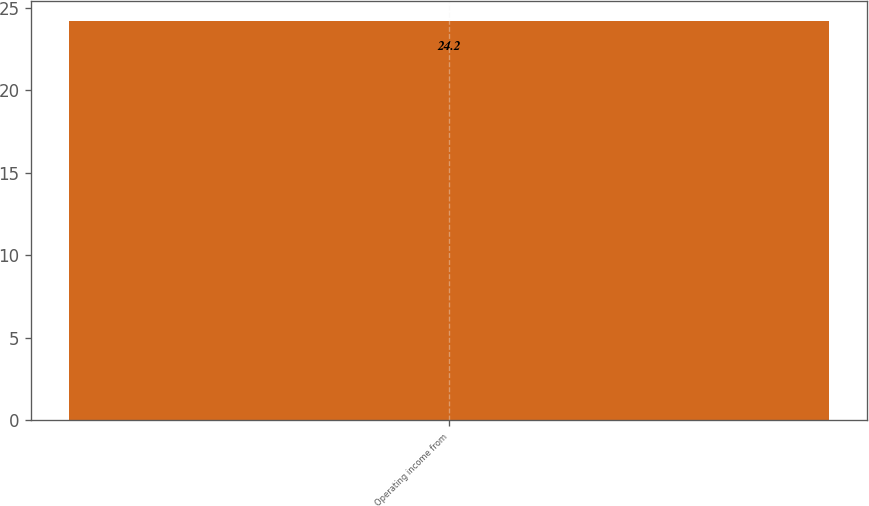Convert chart. <chart><loc_0><loc_0><loc_500><loc_500><bar_chart><fcel>Operating income from<nl><fcel>24.2<nl></chart> 